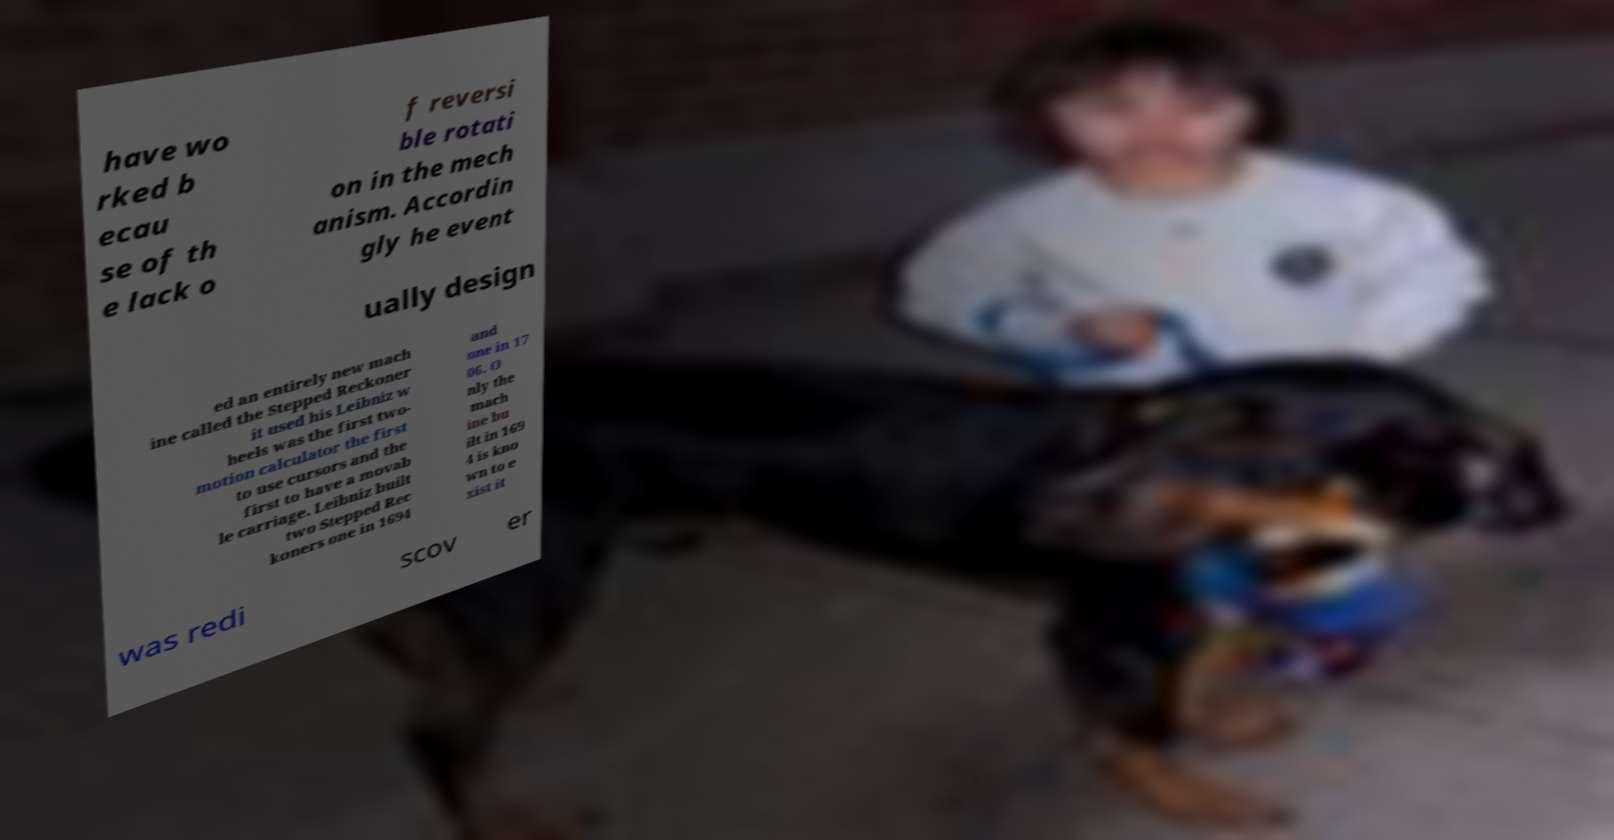I need the written content from this picture converted into text. Can you do that? have wo rked b ecau se of th e lack o f reversi ble rotati on in the mech anism. Accordin gly he event ually design ed an entirely new mach ine called the Stepped Reckoner it used his Leibniz w heels was the first two- motion calculator the first to use cursors and the first to have a movab le carriage. Leibniz built two Stepped Rec koners one in 1694 and one in 17 06. O nly the mach ine bu ilt in 169 4 is kno wn to e xist it was redi scov er 